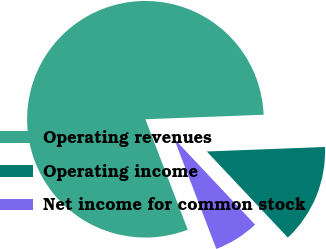Convert chart to OTSL. <chart><loc_0><loc_0><loc_500><loc_500><pie_chart><fcel>Operating revenues<fcel>Operating income<fcel>Net income for common stock<nl><fcel>80.22%<fcel>13.59%<fcel>6.19%<nl></chart> 